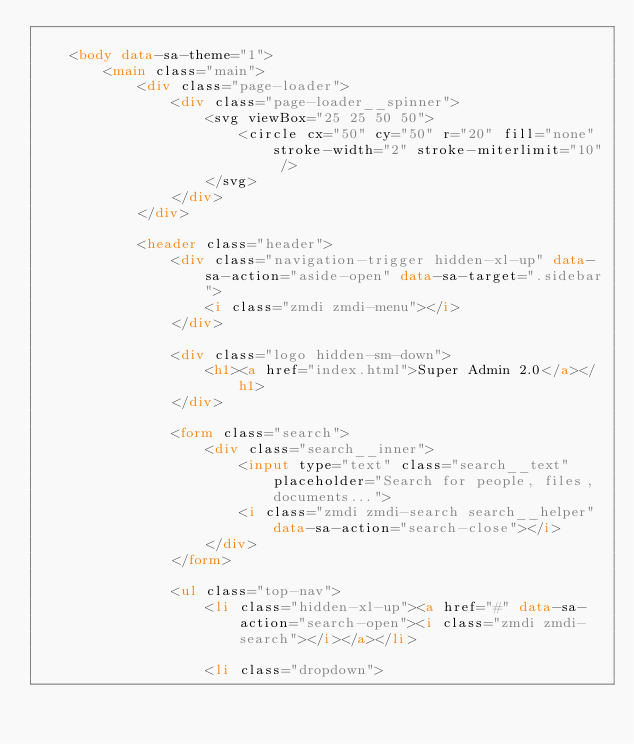Convert code to text. <code><loc_0><loc_0><loc_500><loc_500><_HTML_>
    <body data-sa-theme="1">
        <main class="main">
            <div class="page-loader">
                <div class="page-loader__spinner">
                    <svg viewBox="25 25 50 50">
                        <circle cx="50" cy="50" r="20" fill="none" stroke-width="2" stroke-miterlimit="10" />
                    </svg>
                </div>
            </div>

            <header class="header">
                <div class="navigation-trigger hidden-xl-up" data-sa-action="aside-open" data-sa-target=".sidebar">
                    <i class="zmdi zmdi-menu"></i>
                </div>

                <div class="logo hidden-sm-down">
                    <h1><a href="index.html">Super Admin 2.0</a></h1>
                </div>

                <form class="search">
                    <div class="search__inner">
                        <input type="text" class="search__text" placeholder="Search for people, files, documents...">
                        <i class="zmdi zmdi-search search__helper" data-sa-action="search-close"></i>
                    </div>
                </form>

                <ul class="top-nav">
                    <li class="hidden-xl-up"><a href="#" data-sa-action="search-open"><i class="zmdi zmdi-search"></i></a></li>

                    <li class="dropdown"></code> 